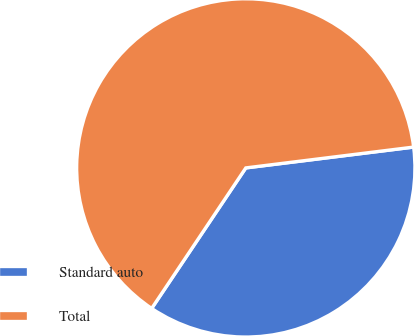<chart> <loc_0><loc_0><loc_500><loc_500><pie_chart><fcel>Standard auto<fcel>Total<nl><fcel>36.36%<fcel>63.64%<nl></chart> 